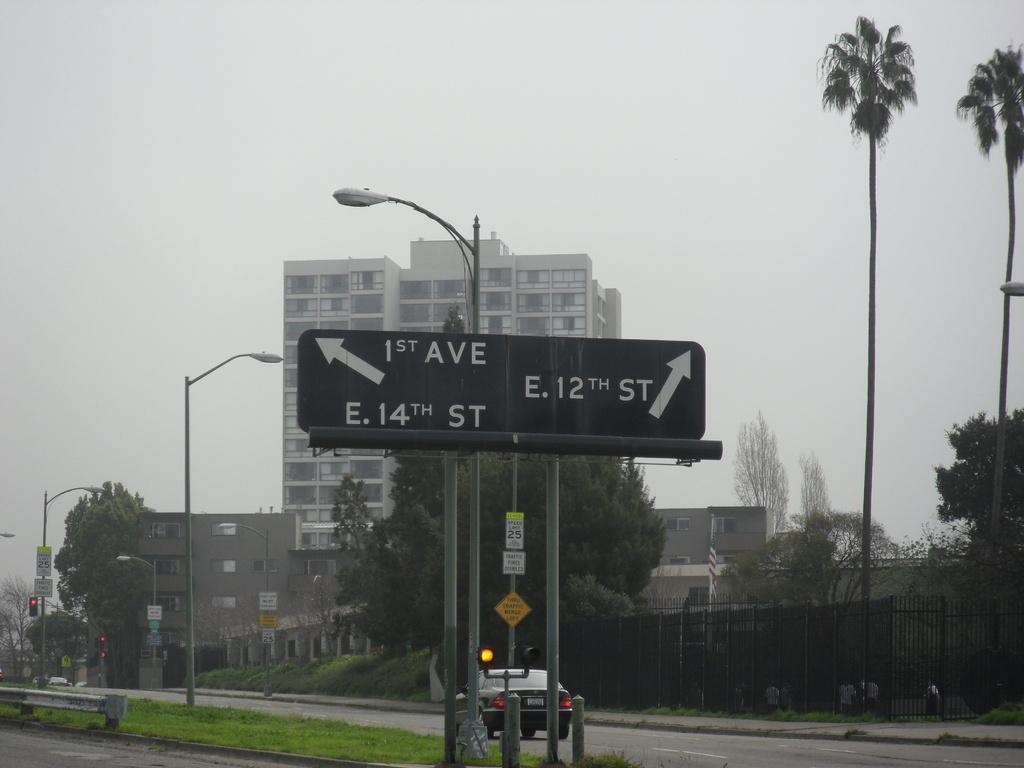How would you summarize this image in a sentence or two? In this picture there is a sign pole in the center of the image and there is grassland at the bottom side of the image, there is a car on the road at the bottom side of the image, there are trees and buildings in the image. 